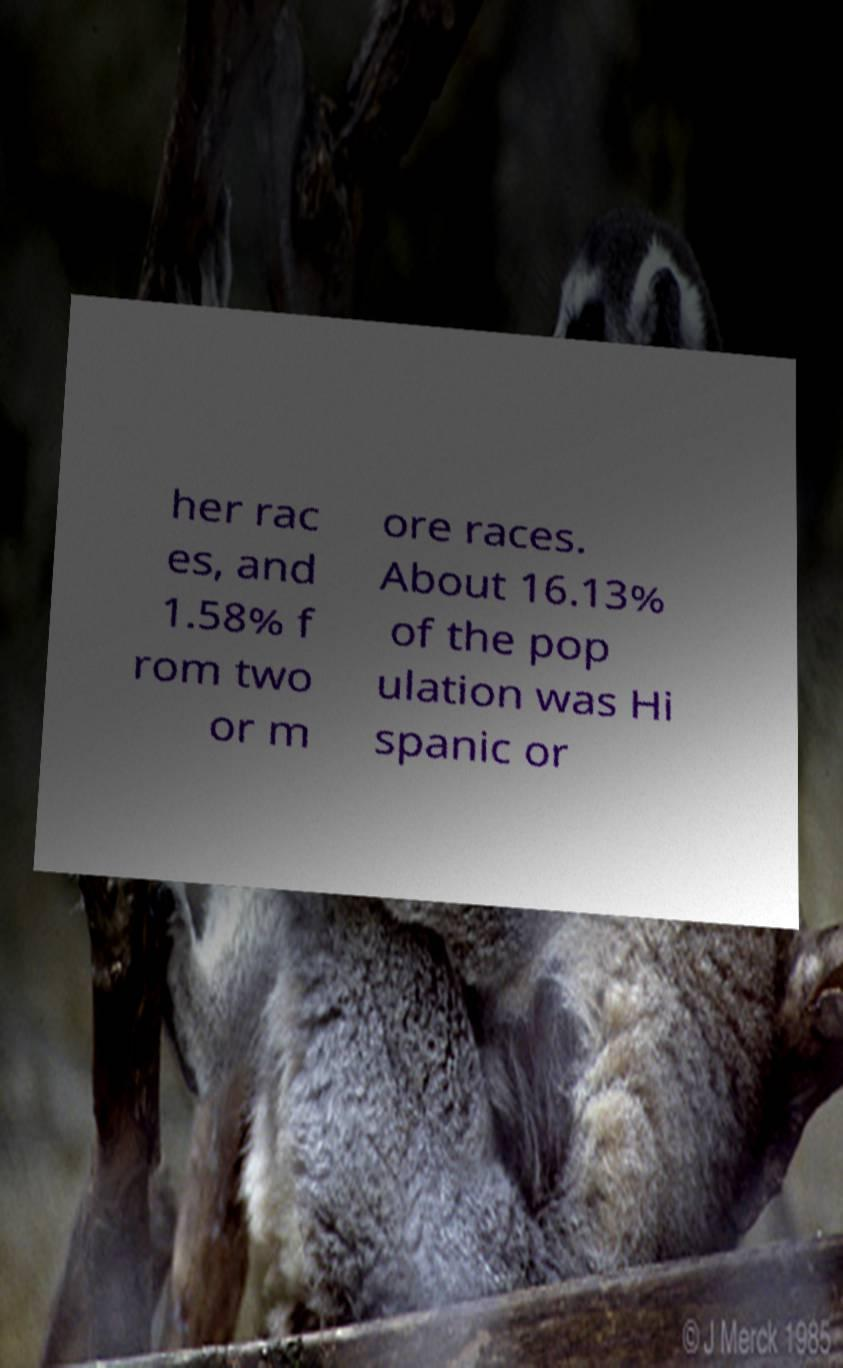For documentation purposes, I need the text within this image transcribed. Could you provide that? her rac es, and 1.58% f rom two or m ore races. About 16.13% of the pop ulation was Hi spanic or 